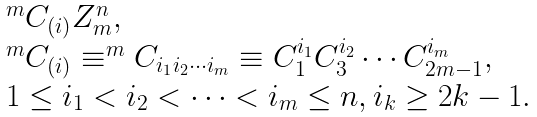Convert formula to latex. <formula><loc_0><loc_0><loc_500><loc_500>\begin{array} { r c l } & & { ^ { m } C _ { ( i ) } } Z ^ { n } _ { m } , \\ & & { ^ { m } C _ { ( i ) } } \equiv ^ { m } C _ { i _ { 1 } i _ { 2 } \cdots i _ { m } } \equiv C ^ { i _ { 1 } } _ { 1 } C ^ { i _ { 2 } } _ { 3 } \cdots C ^ { i _ { m } } _ { 2 m - 1 } , \\ & & 1 \leq i _ { 1 } < i _ { 2 } < \cdots < i _ { m } \leq n , i _ { k } \geq 2 k - 1 . \end{array}</formula> 